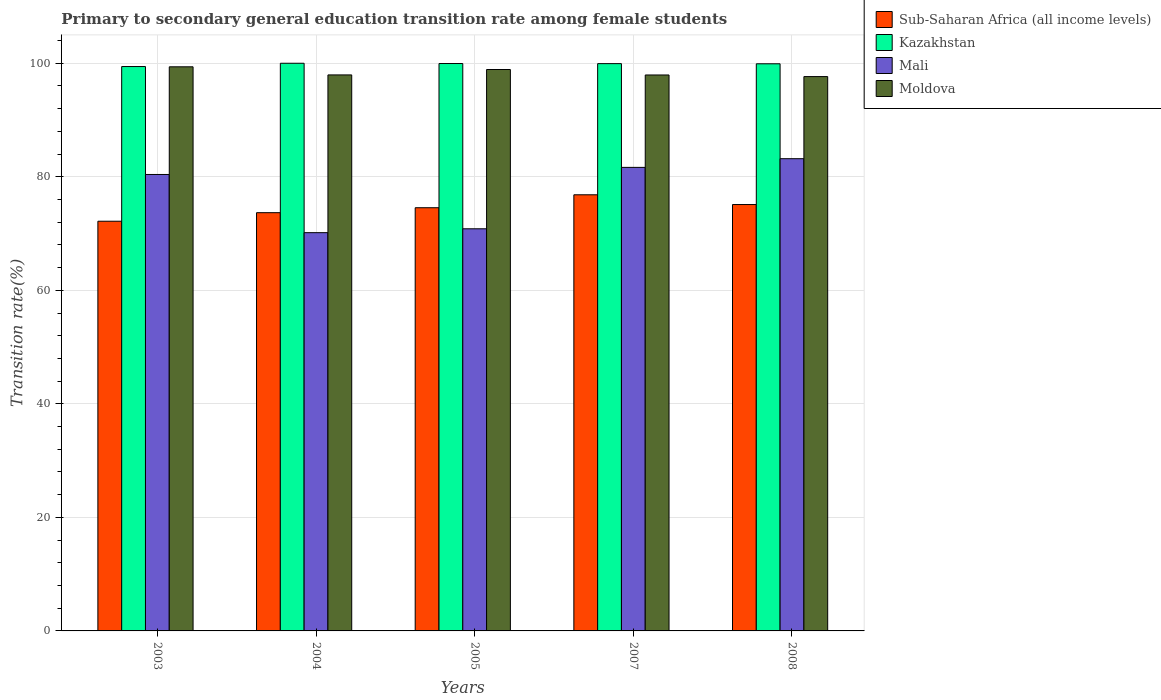How many different coloured bars are there?
Provide a short and direct response. 4. How many groups of bars are there?
Offer a very short reply. 5. How many bars are there on the 4th tick from the left?
Provide a short and direct response. 4. In how many cases, is the number of bars for a given year not equal to the number of legend labels?
Keep it short and to the point. 0. What is the transition rate in Mali in 2005?
Provide a short and direct response. 70.84. Across all years, what is the maximum transition rate in Sub-Saharan Africa (all income levels)?
Provide a succinct answer. 76.83. Across all years, what is the minimum transition rate in Sub-Saharan Africa (all income levels)?
Offer a terse response. 72.17. In which year was the transition rate in Mali maximum?
Ensure brevity in your answer.  2008. What is the total transition rate in Moldova in the graph?
Your response must be concise. 491.81. What is the difference between the transition rate in Moldova in 2003 and that in 2008?
Provide a short and direct response. 1.72. What is the difference between the transition rate in Mali in 2008 and the transition rate in Kazakhstan in 2003?
Provide a succinct answer. -16.23. What is the average transition rate in Moldova per year?
Your response must be concise. 98.36. In the year 2004, what is the difference between the transition rate in Kazakhstan and transition rate in Mali?
Keep it short and to the point. 29.84. What is the ratio of the transition rate in Kazakhstan in 2003 to that in 2007?
Provide a succinct answer. 0.99. What is the difference between the highest and the second highest transition rate in Mali?
Make the answer very short. 1.53. What is the difference between the highest and the lowest transition rate in Moldova?
Your answer should be compact. 1.72. Is the sum of the transition rate in Moldova in 2004 and 2005 greater than the maximum transition rate in Sub-Saharan Africa (all income levels) across all years?
Ensure brevity in your answer.  Yes. Is it the case that in every year, the sum of the transition rate in Mali and transition rate in Sub-Saharan Africa (all income levels) is greater than the sum of transition rate in Moldova and transition rate in Kazakhstan?
Your answer should be compact. No. What does the 1st bar from the left in 2008 represents?
Offer a terse response. Sub-Saharan Africa (all income levels). What does the 4th bar from the right in 2003 represents?
Provide a short and direct response. Sub-Saharan Africa (all income levels). Is it the case that in every year, the sum of the transition rate in Sub-Saharan Africa (all income levels) and transition rate in Kazakhstan is greater than the transition rate in Mali?
Your answer should be very brief. Yes. Are all the bars in the graph horizontal?
Make the answer very short. No. How many years are there in the graph?
Ensure brevity in your answer.  5. What is the difference between two consecutive major ticks on the Y-axis?
Your answer should be compact. 20. Does the graph contain any zero values?
Your response must be concise. No. Does the graph contain grids?
Provide a succinct answer. Yes. How many legend labels are there?
Provide a short and direct response. 4. What is the title of the graph?
Keep it short and to the point. Primary to secondary general education transition rate among female students. What is the label or title of the X-axis?
Ensure brevity in your answer.  Years. What is the label or title of the Y-axis?
Offer a very short reply. Transition rate(%). What is the Transition rate(%) of Sub-Saharan Africa (all income levels) in 2003?
Your answer should be very brief. 72.17. What is the Transition rate(%) in Kazakhstan in 2003?
Make the answer very short. 99.42. What is the Transition rate(%) of Mali in 2003?
Your response must be concise. 80.41. What is the Transition rate(%) in Moldova in 2003?
Provide a succinct answer. 99.37. What is the Transition rate(%) in Sub-Saharan Africa (all income levels) in 2004?
Make the answer very short. 73.68. What is the Transition rate(%) in Mali in 2004?
Offer a very short reply. 70.16. What is the Transition rate(%) of Moldova in 2004?
Provide a short and direct response. 97.95. What is the Transition rate(%) in Sub-Saharan Africa (all income levels) in 2005?
Your response must be concise. 74.55. What is the Transition rate(%) in Kazakhstan in 2005?
Make the answer very short. 99.95. What is the Transition rate(%) of Mali in 2005?
Provide a short and direct response. 70.84. What is the Transition rate(%) of Moldova in 2005?
Your answer should be very brief. 98.9. What is the Transition rate(%) in Sub-Saharan Africa (all income levels) in 2007?
Give a very brief answer. 76.83. What is the Transition rate(%) in Kazakhstan in 2007?
Ensure brevity in your answer.  99.93. What is the Transition rate(%) of Mali in 2007?
Your answer should be very brief. 81.66. What is the Transition rate(%) of Moldova in 2007?
Make the answer very short. 97.93. What is the Transition rate(%) in Sub-Saharan Africa (all income levels) in 2008?
Provide a short and direct response. 75.11. What is the Transition rate(%) of Kazakhstan in 2008?
Make the answer very short. 99.91. What is the Transition rate(%) in Mali in 2008?
Ensure brevity in your answer.  83.19. What is the Transition rate(%) of Moldova in 2008?
Make the answer very short. 97.65. Across all years, what is the maximum Transition rate(%) in Sub-Saharan Africa (all income levels)?
Your answer should be very brief. 76.83. Across all years, what is the maximum Transition rate(%) in Kazakhstan?
Offer a very short reply. 100. Across all years, what is the maximum Transition rate(%) of Mali?
Make the answer very short. 83.19. Across all years, what is the maximum Transition rate(%) of Moldova?
Give a very brief answer. 99.37. Across all years, what is the minimum Transition rate(%) in Sub-Saharan Africa (all income levels)?
Offer a very short reply. 72.17. Across all years, what is the minimum Transition rate(%) of Kazakhstan?
Your response must be concise. 99.42. Across all years, what is the minimum Transition rate(%) of Mali?
Keep it short and to the point. 70.16. Across all years, what is the minimum Transition rate(%) in Moldova?
Ensure brevity in your answer.  97.65. What is the total Transition rate(%) of Sub-Saharan Africa (all income levels) in the graph?
Make the answer very short. 372.34. What is the total Transition rate(%) of Kazakhstan in the graph?
Offer a very short reply. 499.21. What is the total Transition rate(%) in Mali in the graph?
Your answer should be very brief. 386.25. What is the total Transition rate(%) of Moldova in the graph?
Keep it short and to the point. 491.81. What is the difference between the Transition rate(%) in Sub-Saharan Africa (all income levels) in 2003 and that in 2004?
Your answer should be very brief. -1.51. What is the difference between the Transition rate(%) of Kazakhstan in 2003 and that in 2004?
Your answer should be compact. -0.58. What is the difference between the Transition rate(%) of Mali in 2003 and that in 2004?
Offer a terse response. 10.25. What is the difference between the Transition rate(%) of Moldova in 2003 and that in 2004?
Make the answer very short. 1.43. What is the difference between the Transition rate(%) in Sub-Saharan Africa (all income levels) in 2003 and that in 2005?
Give a very brief answer. -2.38. What is the difference between the Transition rate(%) of Kazakhstan in 2003 and that in 2005?
Offer a terse response. -0.53. What is the difference between the Transition rate(%) of Mali in 2003 and that in 2005?
Your answer should be compact. 9.57. What is the difference between the Transition rate(%) in Moldova in 2003 and that in 2005?
Provide a succinct answer. 0.48. What is the difference between the Transition rate(%) of Sub-Saharan Africa (all income levels) in 2003 and that in 2007?
Ensure brevity in your answer.  -4.66. What is the difference between the Transition rate(%) of Kazakhstan in 2003 and that in 2007?
Offer a very short reply. -0.51. What is the difference between the Transition rate(%) of Mali in 2003 and that in 2007?
Give a very brief answer. -1.25. What is the difference between the Transition rate(%) in Moldova in 2003 and that in 2007?
Give a very brief answer. 1.44. What is the difference between the Transition rate(%) in Sub-Saharan Africa (all income levels) in 2003 and that in 2008?
Provide a succinct answer. -2.94. What is the difference between the Transition rate(%) of Kazakhstan in 2003 and that in 2008?
Offer a very short reply. -0.49. What is the difference between the Transition rate(%) in Mali in 2003 and that in 2008?
Provide a short and direct response. -2.78. What is the difference between the Transition rate(%) in Moldova in 2003 and that in 2008?
Provide a succinct answer. 1.72. What is the difference between the Transition rate(%) in Sub-Saharan Africa (all income levels) in 2004 and that in 2005?
Your response must be concise. -0.87. What is the difference between the Transition rate(%) of Kazakhstan in 2004 and that in 2005?
Your response must be concise. 0.05. What is the difference between the Transition rate(%) in Mali in 2004 and that in 2005?
Ensure brevity in your answer.  -0.68. What is the difference between the Transition rate(%) of Moldova in 2004 and that in 2005?
Provide a short and direct response. -0.95. What is the difference between the Transition rate(%) in Sub-Saharan Africa (all income levels) in 2004 and that in 2007?
Your answer should be very brief. -3.15. What is the difference between the Transition rate(%) of Kazakhstan in 2004 and that in 2007?
Give a very brief answer. 0.07. What is the difference between the Transition rate(%) of Mali in 2004 and that in 2007?
Keep it short and to the point. -11.5. What is the difference between the Transition rate(%) of Moldova in 2004 and that in 2007?
Offer a very short reply. 0.01. What is the difference between the Transition rate(%) of Sub-Saharan Africa (all income levels) in 2004 and that in 2008?
Provide a short and direct response. -1.43. What is the difference between the Transition rate(%) in Kazakhstan in 2004 and that in 2008?
Provide a succinct answer. 0.09. What is the difference between the Transition rate(%) of Mali in 2004 and that in 2008?
Offer a terse response. -13.03. What is the difference between the Transition rate(%) in Moldova in 2004 and that in 2008?
Make the answer very short. 0.29. What is the difference between the Transition rate(%) of Sub-Saharan Africa (all income levels) in 2005 and that in 2007?
Offer a terse response. -2.28. What is the difference between the Transition rate(%) of Kazakhstan in 2005 and that in 2007?
Your answer should be very brief. 0.02. What is the difference between the Transition rate(%) in Mali in 2005 and that in 2007?
Your response must be concise. -10.82. What is the difference between the Transition rate(%) of Moldova in 2005 and that in 2007?
Keep it short and to the point. 0.96. What is the difference between the Transition rate(%) of Sub-Saharan Africa (all income levels) in 2005 and that in 2008?
Provide a succinct answer. -0.56. What is the difference between the Transition rate(%) in Kazakhstan in 2005 and that in 2008?
Provide a succinct answer. 0.05. What is the difference between the Transition rate(%) in Mali in 2005 and that in 2008?
Give a very brief answer. -12.35. What is the difference between the Transition rate(%) in Moldova in 2005 and that in 2008?
Offer a very short reply. 1.25. What is the difference between the Transition rate(%) in Sub-Saharan Africa (all income levels) in 2007 and that in 2008?
Give a very brief answer. 1.72. What is the difference between the Transition rate(%) in Kazakhstan in 2007 and that in 2008?
Your answer should be compact. 0.03. What is the difference between the Transition rate(%) of Mali in 2007 and that in 2008?
Your answer should be very brief. -1.53. What is the difference between the Transition rate(%) of Moldova in 2007 and that in 2008?
Your response must be concise. 0.28. What is the difference between the Transition rate(%) of Sub-Saharan Africa (all income levels) in 2003 and the Transition rate(%) of Kazakhstan in 2004?
Your response must be concise. -27.83. What is the difference between the Transition rate(%) in Sub-Saharan Africa (all income levels) in 2003 and the Transition rate(%) in Mali in 2004?
Your answer should be compact. 2.01. What is the difference between the Transition rate(%) in Sub-Saharan Africa (all income levels) in 2003 and the Transition rate(%) in Moldova in 2004?
Your answer should be very brief. -25.77. What is the difference between the Transition rate(%) of Kazakhstan in 2003 and the Transition rate(%) of Mali in 2004?
Provide a succinct answer. 29.26. What is the difference between the Transition rate(%) of Kazakhstan in 2003 and the Transition rate(%) of Moldova in 2004?
Offer a terse response. 1.48. What is the difference between the Transition rate(%) of Mali in 2003 and the Transition rate(%) of Moldova in 2004?
Offer a very short reply. -17.54. What is the difference between the Transition rate(%) in Sub-Saharan Africa (all income levels) in 2003 and the Transition rate(%) in Kazakhstan in 2005?
Your answer should be compact. -27.78. What is the difference between the Transition rate(%) of Sub-Saharan Africa (all income levels) in 2003 and the Transition rate(%) of Mali in 2005?
Offer a terse response. 1.33. What is the difference between the Transition rate(%) of Sub-Saharan Africa (all income levels) in 2003 and the Transition rate(%) of Moldova in 2005?
Your answer should be very brief. -26.73. What is the difference between the Transition rate(%) in Kazakhstan in 2003 and the Transition rate(%) in Mali in 2005?
Your answer should be very brief. 28.58. What is the difference between the Transition rate(%) of Kazakhstan in 2003 and the Transition rate(%) of Moldova in 2005?
Make the answer very short. 0.52. What is the difference between the Transition rate(%) in Mali in 2003 and the Transition rate(%) in Moldova in 2005?
Offer a very short reply. -18.49. What is the difference between the Transition rate(%) of Sub-Saharan Africa (all income levels) in 2003 and the Transition rate(%) of Kazakhstan in 2007?
Ensure brevity in your answer.  -27.76. What is the difference between the Transition rate(%) of Sub-Saharan Africa (all income levels) in 2003 and the Transition rate(%) of Mali in 2007?
Keep it short and to the point. -9.49. What is the difference between the Transition rate(%) in Sub-Saharan Africa (all income levels) in 2003 and the Transition rate(%) in Moldova in 2007?
Give a very brief answer. -25.76. What is the difference between the Transition rate(%) of Kazakhstan in 2003 and the Transition rate(%) of Mali in 2007?
Provide a succinct answer. 17.76. What is the difference between the Transition rate(%) of Kazakhstan in 2003 and the Transition rate(%) of Moldova in 2007?
Offer a terse response. 1.49. What is the difference between the Transition rate(%) of Mali in 2003 and the Transition rate(%) of Moldova in 2007?
Provide a short and direct response. -17.53. What is the difference between the Transition rate(%) of Sub-Saharan Africa (all income levels) in 2003 and the Transition rate(%) of Kazakhstan in 2008?
Provide a short and direct response. -27.74. What is the difference between the Transition rate(%) in Sub-Saharan Africa (all income levels) in 2003 and the Transition rate(%) in Mali in 2008?
Offer a terse response. -11.02. What is the difference between the Transition rate(%) in Sub-Saharan Africa (all income levels) in 2003 and the Transition rate(%) in Moldova in 2008?
Provide a short and direct response. -25.48. What is the difference between the Transition rate(%) in Kazakhstan in 2003 and the Transition rate(%) in Mali in 2008?
Offer a terse response. 16.23. What is the difference between the Transition rate(%) of Kazakhstan in 2003 and the Transition rate(%) of Moldova in 2008?
Your answer should be compact. 1.77. What is the difference between the Transition rate(%) in Mali in 2003 and the Transition rate(%) in Moldova in 2008?
Make the answer very short. -17.24. What is the difference between the Transition rate(%) in Sub-Saharan Africa (all income levels) in 2004 and the Transition rate(%) in Kazakhstan in 2005?
Your answer should be very brief. -26.27. What is the difference between the Transition rate(%) of Sub-Saharan Africa (all income levels) in 2004 and the Transition rate(%) of Mali in 2005?
Your response must be concise. 2.84. What is the difference between the Transition rate(%) of Sub-Saharan Africa (all income levels) in 2004 and the Transition rate(%) of Moldova in 2005?
Offer a very short reply. -25.22. What is the difference between the Transition rate(%) of Kazakhstan in 2004 and the Transition rate(%) of Mali in 2005?
Provide a short and direct response. 29.16. What is the difference between the Transition rate(%) of Kazakhstan in 2004 and the Transition rate(%) of Moldova in 2005?
Provide a succinct answer. 1.1. What is the difference between the Transition rate(%) in Mali in 2004 and the Transition rate(%) in Moldova in 2005?
Ensure brevity in your answer.  -28.74. What is the difference between the Transition rate(%) in Sub-Saharan Africa (all income levels) in 2004 and the Transition rate(%) in Kazakhstan in 2007?
Provide a succinct answer. -26.25. What is the difference between the Transition rate(%) of Sub-Saharan Africa (all income levels) in 2004 and the Transition rate(%) of Mali in 2007?
Offer a terse response. -7.98. What is the difference between the Transition rate(%) in Sub-Saharan Africa (all income levels) in 2004 and the Transition rate(%) in Moldova in 2007?
Offer a terse response. -24.26. What is the difference between the Transition rate(%) of Kazakhstan in 2004 and the Transition rate(%) of Mali in 2007?
Your response must be concise. 18.34. What is the difference between the Transition rate(%) of Kazakhstan in 2004 and the Transition rate(%) of Moldova in 2007?
Offer a very short reply. 2.07. What is the difference between the Transition rate(%) of Mali in 2004 and the Transition rate(%) of Moldova in 2007?
Your answer should be compact. -27.78. What is the difference between the Transition rate(%) of Sub-Saharan Africa (all income levels) in 2004 and the Transition rate(%) of Kazakhstan in 2008?
Keep it short and to the point. -26.23. What is the difference between the Transition rate(%) in Sub-Saharan Africa (all income levels) in 2004 and the Transition rate(%) in Mali in 2008?
Provide a succinct answer. -9.51. What is the difference between the Transition rate(%) of Sub-Saharan Africa (all income levels) in 2004 and the Transition rate(%) of Moldova in 2008?
Your response must be concise. -23.97. What is the difference between the Transition rate(%) of Kazakhstan in 2004 and the Transition rate(%) of Mali in 2008?
Make the answer very short. 16.81. What is the difference between the Transition rate(%) of Kazakhstan in 2004 and the Transition rate(%) of Moldova in 2008?
Give a very brief answer. 2.35. What is the difference between the Transition rate(%) in Mali in 2004 and the Transition rate(%) in Moldova in 2008?
Ensure brevity in your answer.  -27.5. What is the difference between the Transition rate(%) in Sub-Saharan Africa (all income levels) in 2005 and the Transition rate(%) in Kazakhstan in 2007?
Your response must be concise. -25.38. What is the difference between the Transition rate(%) in Sub-Saharan Africa (all income levels) in 2005 and the Transition rate(%) in Mali in 2007?
Provide a short and direct response. -7.11. What is the difference between the Transition rate(%) of Sub-Saharan Africa (all income levels) in 2005 and the Transition rate(%) of Moldova in 2007?
Offer a very short reply. -23.39. What is the difference between the Transition rate(%) of Kazakhstan in 2005 and the Transition rate(%) of Mali in 2007?
Keep it short and to the point. 18.29. What is the difference between the Transition rate(%) in Kazakhstan in 2005 and the Transition rate(%) in Moldova in 2007?
Give a very brief answer. 2.02. What is the difference between the Transition rate(%) in Mali in 2005 and the Transition rate(%) in Moldova in 2007?
Your answer should be compact. -27.09. What is the difference between the Transition rate(%) of Sub-Saharan Africa (all income levels) in 2005 and the Transition rate(%) of Kazakhstan in 2008?
Offer a terse response. -25.36. What is the difference between the Transition rate(%) in Sub-Saharan Africa (all income levels) in 2005 and the Transition rate(%) in Mali in 2008?
Ensure brevity in your answer.  -8.64. What is the difference between the Transition rate(%) in Sub-Saharan Africa (all income levels) in 2005 and the Transition rate(%) in Moldova in 2008?
Provide a succinct answer. -23.1. What is the difference between the Transition rate(%) of Kazakhstan in 2005 and the Transition rate(%) of Mali in 2008?
Offer a terse response. 16.77. What is the difference between the Transition rate(%) of Kazakhstan in 2005 and the Transition rate(%) of Moldova in 2008?
Offer a very short reply. 2.3. What is the difference between the Transition rate(%) in Mali in 2005 and the Transition rate(%) in Moldova in 2008?
Make the answer very short. -26.81. What is the difference between the Transition rate(%) of Sub-Saharan Africa (all income levels) in 2007 and the Transition rate(%) of Kazakhstan in 2008?
Your answer should be compact. -23.08. What is the difference between the Transition rate(%) in Sub-Saharan Africa (all income levels) in 2007 and the Transition rate(%) in Mali in 2008?
Offer a terse response. -6.36. What is the difference between the Transition rate(%) in Sub-Saharan Africa (all income levels) in 2007 and the Transition rate(%) in Moldova in 2008?
Ensure brevity in your answer.  -20.82. What is the difference between the Transition rate(%) in Kazakhstan in 2007 and the Transition rate(%) in Mali in 2008?
Your answer should be compact. 16.75. What is the difference between the Transition rate(%) of Kazakhstan in 2007 and the Transition rate(%) of Moldova in 2008?
Offer a very short reply. 2.28. What is the difference between the Transition rate(%) of Mali in 2007 and the Transition rate(%) of Moldova in 2008?
Offer a terse response. -15.99. What is the average Transition rate(%) in Sub-Saharan Africa (all income levels) per year?
Your response must be concise. 74.47. What is the average Transition rate(%) of Kazakhstan per year?
Provide a succinct answer. 99.84. What is the average Transition rate(%) of Mali per year?
Keep it short and to the point. 77.25. What is the average Transition rate(%) of Moldova per year?
Your response must be concise. 98.36. In the year 2003, what is the difference between the Transition rate(%) of Sub-Saharan Africa (all income levels) and Transition rate(%) of Kazakhstan?
Your answer should be very brief. -27.25. In the year 2003, what is the difference between the Transition rate(%) in Sub-Saharan Africa (all income levels) and Transition rate(%) in Mali?
Give a very brief answer. -8.24. In the year 2003, what is the difference between the Transition rate(%) in Sub-Saharan Africa (all income levels) and Transition rate(%) in Moldova?
Give a very brief answer. -27.2. In the year 2003, what is the difference between the Transition rate(%) of Kazakhstan and Transition rate(%) of Mali?
Give a very brief answer. 19.01. In the year 2003, what is the difference between the Transition rate(%) in Kazakhstan and Transition rate(%) in Moldova?
Provide a succinct answer. 0.05. In the year 2003, what is the difference between the Transition rate(%) in Mali and Transition rate(%) in Moldova?
Offer a very short reply. -18.97. In the year 2004, what is the difference between the Transition rate(%) in Sub-Saharan Africa (all income levels) and Transition rate(%) in Kazakhstan?
Offer a very short reply. -26.32. In the year 2004, what is the difference between the Transition rate(%) in Sub-Saharan Africa (all income levels) and Transition rate(%) in Mali?
Your response must be concise. 3.52. In the year 2004, what is the difference between the Transition rate(%) of Sub-Saharan Africa (all income levels) and Transition rate(%) of Moldova?
Keep it short and to the point. -24.27. In the year 2004, what is the difference between the Transition rate(%) in Kazakhstan and Transition rate(%) in Mali?
Your answer should be compact. 29.84. In the year 2004, what is the difference between the Transition rate(%) in Kazakhstan and Transition rate(%) in Moldova?
Ensure brevity in your answer.  2.05. In the year 2004, what is the difference between the Transition rate(%) in Mali and Transition rate(%) in Moldova?
Provide a short and direct response. -27.79. In the year 2005, what is the difference between the Transition rate(%) of Sub-Saharan Africa (all income levels) and Transition rate(%) of Kazakhstan?
Your answer should be compact. -25.4. In the year 2005, what is the difference between the Transition rate(%) of Sub-Saharan Africa (all income levels) and Transition rate(%) of Mali?
Give a very brief answer. 3.71. In the year 2005, what is the difference between the Transition rate(%) in Sub-Saharan Africa (all income levels) and Transition rate(%) in Moldova?
Your answer should be very brief. -24.35. In the year 2005, what is the difference between the Transition rate(%) of Kazakhstan and Transition rate(%) of Mali?
Keep it short and to the point. 29.11. In the year 2005, what is the difference between the Transition rate(%) of Kazakhstan and Transition rate(%) of Moldova?
Your response must be concise. 1.05. In the year 2005, what is the difference between the Transition rate(%) in Mali and Transition rate(%) in Moldova?
Ensure brevity in your answer.  -28.06. In the year 2007, what is the difference between the Transition rate(%) in Sub-Saharan Africa (all income levels) and Transition rate(%) in Kazakhstan?
Your response must be concise. -23.1. In the year 2007, what is the difference between the Transition rate(%) of Sub-Saharan Africa (all income levels) and Transition rate(%) of Mali?
Offer a terse response. -4.83. In the year 2007, what is the difference between the Transition rate(%) of Sub-Saharan Africa (all income levels) and Transition rate(%) of Moldova?
Your response must be concise. -21.1. In the year 2007, what is the difference between the Transition rate(%) in Kazakhstan and Transition rate(%) in Mali?
Offer a terse response. 18.27. In the year 2007, what is the difference between the Transition rate(%) of Kazakhstan and Transition rate(%) of Moldova?
Your response must be concise. 2. In the year 2007, what is the difference between the Transition rate(%) of Mali and Transition rate(%) of Moldova?
Your response must be concise. -16.28. In the year 2008, what is the difference between the Transition rate(%) of Sub-Saharan Africa (all income levels) and Transition rate(%) of Kazakhstan?
Offer a terse response. -24.8. In the year 2008, what is the difference between the Transition rate(%) of Sub-Saharan Africa (all income levels) and Transition rate(%) of Mali?
Make the answer very short. -8.08. In the year 2008, what is the difference between the Transition rate(%) in Sub-Saharan Africa (all income levels) and Transition rate(%) in Moldova?
Your response must be concise. -22.54. In the year 2008, what is the difference between the Transition rate(%) in Kazakhstan and Transition rate(%) in Mali?
Your answer should be very brief. 16.72. In the year 2008, what is the difference between the Transition rate(%) of Kazakhstan and Transition rate(%) of Moldova?
Your answer should be compact. 2.26. In the year 2008, what is the difference between the Transition rate(%) in Mali and Transition rate(%) in Moldova?
Provide a succinct answer. -14.47. What is the ratio of the Transition rate(%) in Sub-Saharan Africa (all income levels) in 2003 to that in 2004?
Offer a terse response. 0.98. What is the ratio of the Transition rate(%) of Mali in 2003 to that in 2004?
Provide a succinct answer. 1.15. What is the ratio of the Transition rate(%) of Moldova in 2003 to that in 2004?
Your answer should be compact. 1.01. What is the ratio of the Transition rate(%) in Sub-Saharan Africa (all income levels) in 2003 to that in 2005?
Make the answer very short. 0.97. What is the ratio of the Transition rate(%) in Mali in 2003 to that in 2005?
Provide a short and direct response. 1.14. What is the ratio of the Transition rate(%) in Moldova in 2003 to that in 2005?
Offer a terse response. 1. What is the ratio of the Transition rate(%) in Sub-Saharan Africa (all income levels) in 2003 to that in 2007?
Give a very brief answer. 0.94. What is the ratio of the Transition rate(%) in Kazakhstan in 2003 to that in 2007?
Offer a very short reply. 0.99. What is the ratio of the Transition rate(%) in Mali in 2003 to that in 2007?
Make the answer very short. 0.98. What is the ratio of the Transition rate(%) of Moldova in 2003 to that in 2007?
Make the answer very short. 1.01. What is the ratio of the Transition rate(%) in Sub-Saharan Africa (all income levels) in 2003 to that in 2008?
Make the answer very short. 0.96. What is the ratio of the Transition rate(%) of Kazakhstan in 2003 to that in 2008?
Keep it short and to the point. 1. What is the ratio of the Transition rate(%) in Mali in 2003 to that in 2008?
Provide a succinct answer. 0.97. What is the ratio of the Transition rate(%) of Moldova in 2003 to that in 2008?
Offer a very short reply. 1.02. What is the ratio of the Transition rate(%) of Sub-Saharan Africa (all income levels) in 2004 to that in 2005?
Keep it short and to the point. 0.99. What is the ratio of the Transition rate(%) in Mali in 2004 to that in 2007?
Your answer should be very brief. 0.86. What is the ratio of the Transition rate(%) of Moldova in 2004 to that in 2007?
Give a very brief answer. 1. What is the ratio of the Transition rate(%) in Sub-Saharan Africa (all income levels) in 2004 to that in 2008?
Your response must be concise. 0.98. What is the ratio of the Transition rate(%) of Mali in 2004 to that in 2008?
Provide a succinct answer. 0.84. What is the ratio of the Transition rate(%) of Moldova in 2004 to that in 2008?
Make the answer very short. 1. What is the ratio of the Transition rate(%) of Sub-Saharan Africa (all income levels) in 2005 to that in 2007?
Your response must be concise. 0.97. What is the ratio of the Transition rate(%) of Kazakhstan in 2005 to that in 2007?
Your answer should be very brief. 1. What is the ratio of the Transition rate(%) of Mali in 2005 to that in 2007?
Ensure brevity in your answer.  0.87. What is the ratio of the Transition rate(%) of Moldova in 2005 to that in 2007?
Provide a succinct answer. 1.01. What is the ratio of the Transition rate(%) of Mali in 2005 to that in 2008?
Give a very brief answer. 0.85. What is the ratio of the Transition rate(%) of Moldova in 2005 to that in 2008?
Keep it short and to the point. 1.01. What is the ratio of the Transition rate(%) in Sub-Saharan Africa (all income levels) in 2007 to that in 2008?
Offer a terse response. 1.02. What is the ratio of the Transition rate(%) of Mali in 2007 to that in 2008?
Give a very brief answer. 0.98. What is the difference between the highest and the second highest Transition rate(%) of Sub-Saharan Africa (all income levels)?
Your answer should be very brief. 1.72. What is the difference between the highest and the second highest Transition rate(%) of Kazakhstan?
Give a very brief answer. 0.05. What is the difference between the highest and the second highest Transition rate(%) of Mali?
Your answer should be very brief. 1.53. What is the difference between the highest and the second highest Transition rate(%) in Moldova?
Provide a succinct answer. 0.48. What is the difference between the highest and the lowest Transition rate(%) in Sub-Saharan Africa (all income levels)?
Keep it short and to the point. 4.66. What is the difference between the highest and the lowest Transition rate(%) in Kazakhstan?
Your answer should be very brief. 0.58. What is the difference between the highest and the lowest Transition rate(%) in Mali?
Provide a succinct answer. 13.03. What is the difference between the highest and the lowest Transition rate(%) in Moldova?
Your answer should be compact. 1.72. 